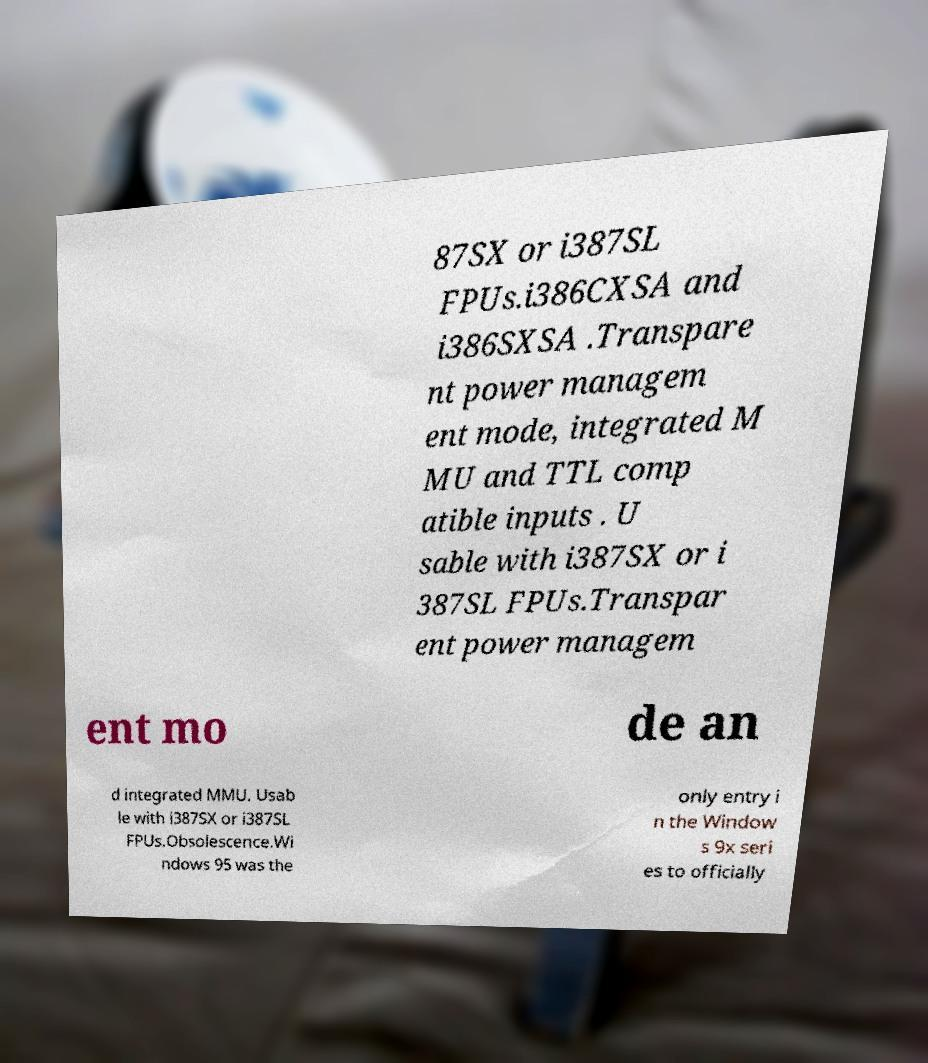Can you accurately transcribe the text from the provided image for me? 87SX or i387SL FPUs.i386CXSA and i386SXSA .Transpare nt power managem ent mode, integrated M MU and TTL comp atible inputs . U sable with i387SX or i 387SL FPUs.Transpar ent power managem ent mo de an d integrated MMU. Usab le with i387SX or i387SL FPUs.Obsolescence.Wi ndows 95 was the only entry i n the Window s 9x seri es to officially 